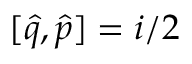<formula> <loc_0><loc_0><loc_500><loc_500>[ \hat { q } , \hat { p } ] = i / 2</formula> 